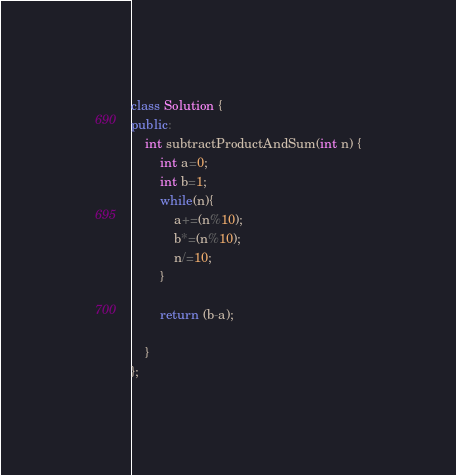Convert code to text. <code><loc_0><loc_0><loc_500><loc_500><_C++_>class Solution {
public:
    int subtractProductAndSum(int n) {
        int a=0;
        int b=1;
        while(n){
            a+=(n%10);
            b*=(n%10);
            n/=10;
        }
        
        return (b-a);
        
    }
};
</code> 